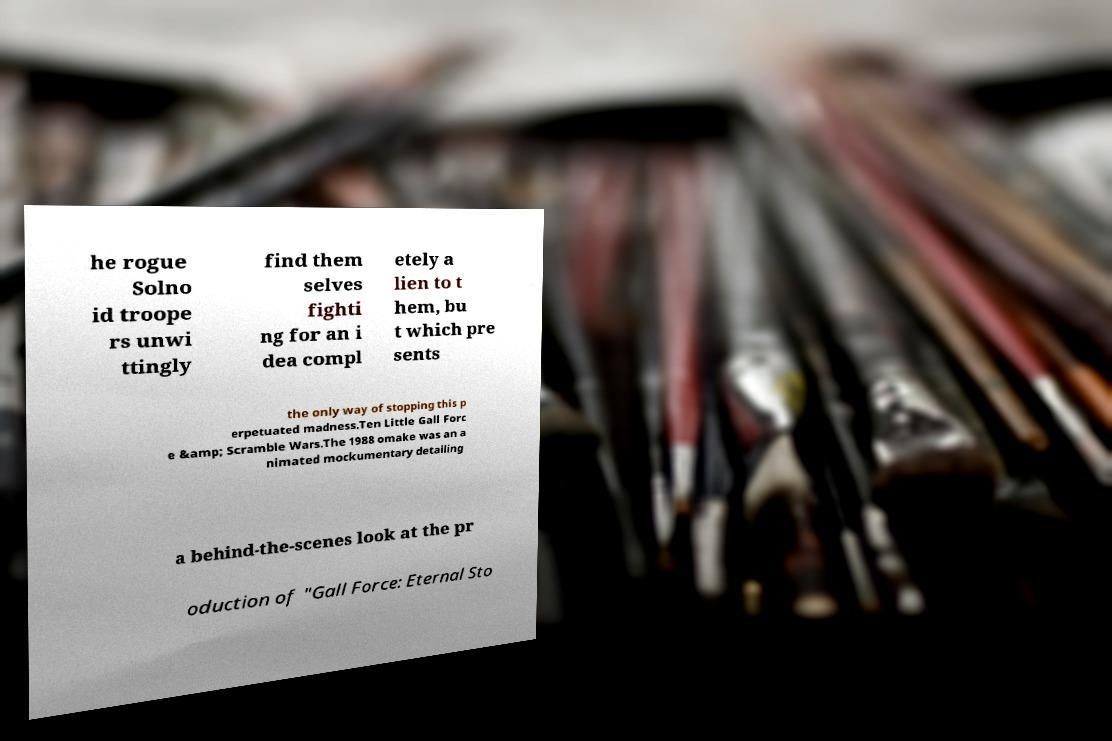Can you read and provide the text displayed in the image?This photo seems to have some interesting text. Can you extract and type it out for me? he rogue Solno id troope rs unwi ttingly find them selves fighti ng for an i dea compl etely a lien to t hem, bu t which pre sents the only way of stopping this p erpetuated madness.Ten Little Gall Forc e &amp; Scramble Wars.The 1988 omake was an a nimated mockumentary detailing a behind-the-scenes look at the pr oduction of "Gall Force: Eternal Sto 